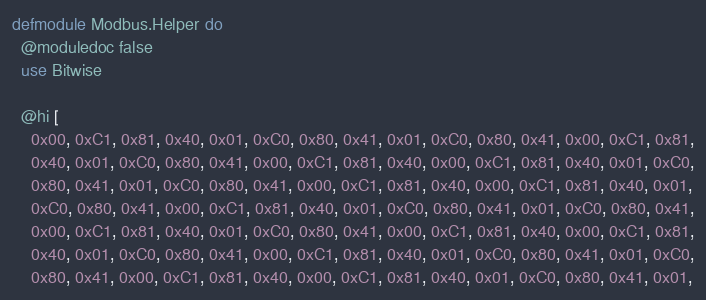<code> <loc_0><loc_0><loc_500><loc_500><_Elixir_>defmodule Modbus.Helper do
  @moduledoc false
  use Bitwise

  @hi [
    0x00, 0xC1, 0x81, 0x40, 0x01, 0xC0, 0x80, 0x41, 0x01, 0xC0, 0x80, 0x41, 0x00, 0xC1, 0x81,
    0x40, 0x01, 0xC0, 0x80, 0x41, 0x00, 0xC1, 0x81, 0x40, 0x00, 0xC1, 0x81, 0x40, 0x01, 0xC0,
    0x80, 0x41, 0x01, 0xC0, 0x80, 0x41, 0x00, 0xC1, 0x81, 0x40, 0x00, 0xC1, 0x81, 0x40, 0x01,
    0xC0, 0x80, 0x41, 0x00, 0xC1, 0x81, 0x40, 0x01, 0xC0, 0x80, 0x41, 0x01, 0xC0, 0x80, 0x41,
    0x00, 0xC1, 0x81, 0x40, 0x01, 0xC0, 0x80, 0x41, 0x00, 0xC1, 0x81, 0x40, 0x00, 0xC1, 0x81,
    0x40, 0x01, 0xC0, 0x80, 0x41, 0x00, 0xC1, 0x81, 0x40, 0x01, 0xC0, 0x80, 0x41, 0x01, 0xC0,
    0x80, 0x41, 0x00, 0xC1, 0x81, 0x40, 0x00, 0xC1, 0x81, 0x40, 0x01, 0xC0, 0x80, 0x41, 0x01,</code> 